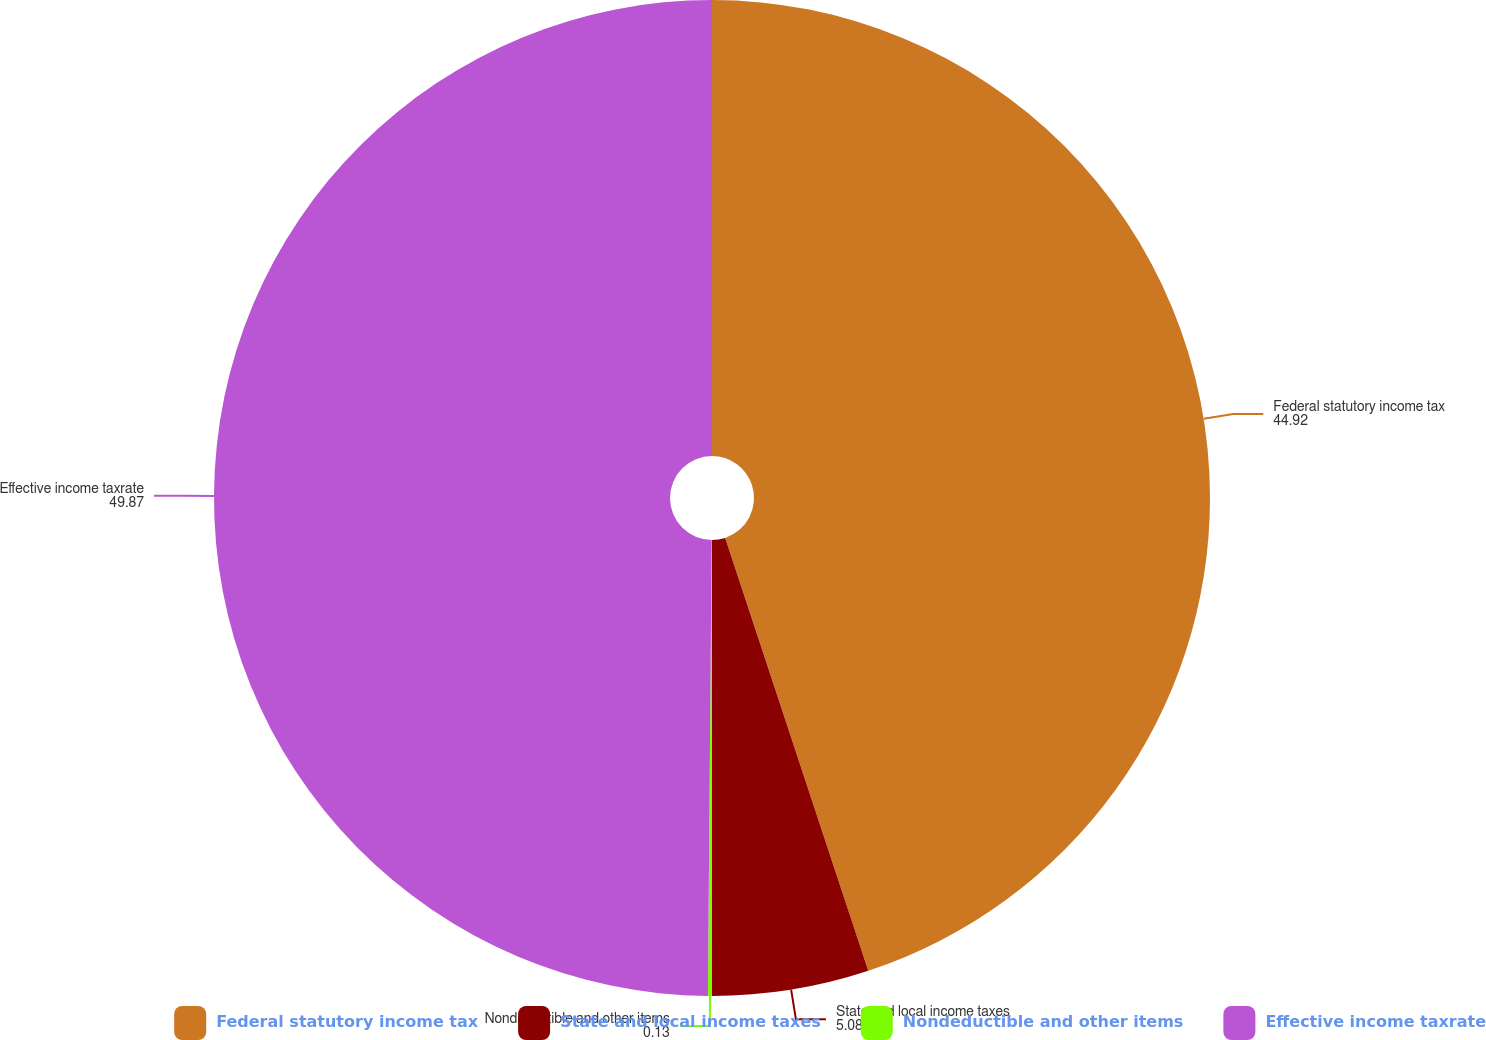Convert chart to OTSL. <chart><loc_0><loc_0><loc_500><loc_500><pie_chart><fcel>Federal statutory income tax<fcel>State and local income taxes<fcel>Nondeductible and other items<fcel>Effective income taxrate<nl><fcel>44.92%<fcel>5.08%<fcel>0.13%<fcel>49.87%<nl></chart> 